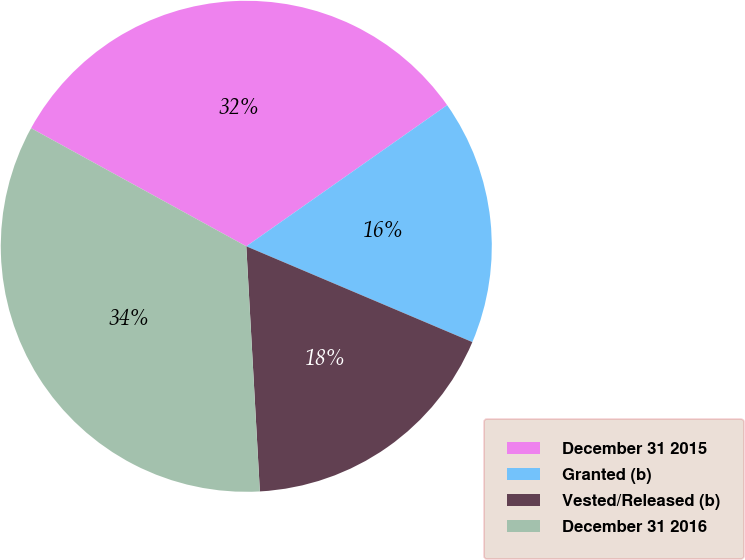<chart> <loc_0><loc_0><loc_500><loc_500><pie_chart><fcel>December 31 2015<fcel>Granted (b)<fcel>Vested/Released (b)<fcel>December 31 2016<nl><fcel>32.26%<fcel>16.13%<fcel>17.74%<fcel>33.87%<nl></chart> 